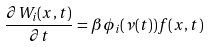<formula> <loc_0><loc_0><loc_500><loc_500>\frac { \partial W _ { i } ( x , t ) } { \partial t } = \beta \phi _ { i } ( \nu ( t ) ) f ( x , t )</formula> 